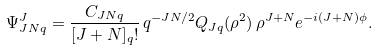Convert formula to latex. <formula><loc_0><loc_0><loc_500><loc_500>\Psi ^ { J } _ { J N q } = \frac { C _ { J N q } } { [ J + N ] _ { q } ! } \, q ^ { - J N / 2 } Q _ { J q } ( \rho ^ { 2 } ) \, \rho ^ { J + N } e ^ { - i ( J + N ) \phi } .</formula> 